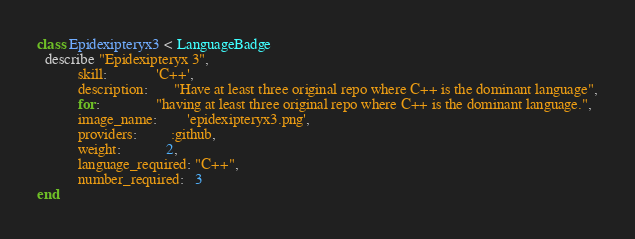Convert code to text. <code><loc_0><loc_0><loc_500><loc_500><_Ruby_>class Epidexipteryx3 < LanguageBadge
  describe "Epidexipteryx 3",
           skill:             'C++',
           description:       "Have at least three original repo where C++ is the dominant language",
           for:               "having at least three original repo where C++ is the dominant language.",
           image_name:        'epidexipteryx3.png',
           providers:         :github,
           weight:            2,
           language_required: "C++",
           number_required:   3
end</code> 